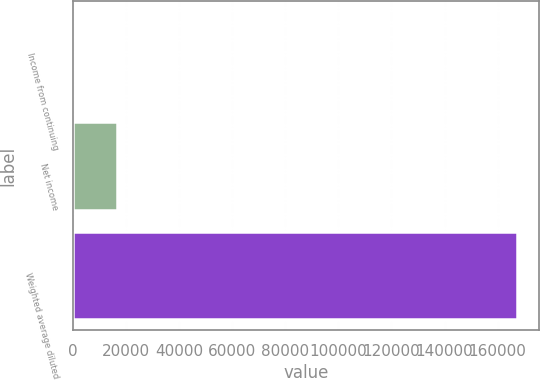Convert chart to OTSL. <chart><loc_0><loc_0><loc_500><loc_500><bar_chart><fcel>Income from continuing<fcel>Net income<fcel>Weighted average diluted<nl><fcel>0.98<fcel>16726.9<fcel>167260<nl></chart> 